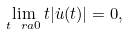<formula> <loc_0><loc_0><loc_500><loc_500>\lim _ { t \ r a 0 } t | \dot { u } ( t ) | = 0 ,</formula> 